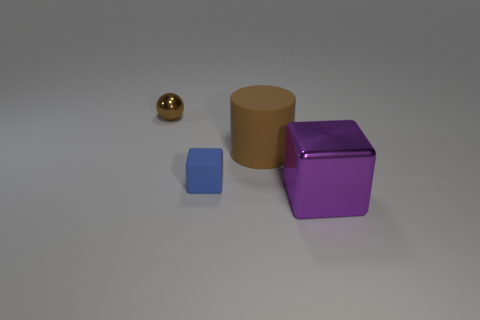Does the image suggest any particular uses or context for these objects? The image appears to be a simple display of geometric shapes with no apparent context that suggests a specific use, resembling an abstract composition or a basic 3D rendering test. 